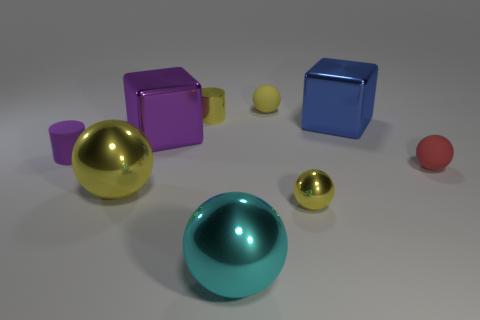How many objects are there in the scene, and can you categorize them by shape and color? There are seven objects in total. Categorizing by shape and color, there are two spheres (one large cyan and one small red), two cubes (one large magenta and one large blue), two cylinders (one small yellow and one small purple), and one small yellow sphere. 